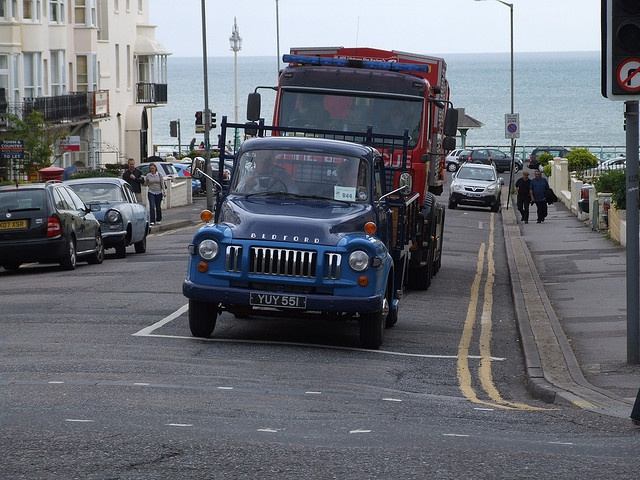Describe the objects in this image and their specific colors. I can see truck in blue, black, gray, navy, and darkblue tones, truck in blue, black, gray, and maroon tones, car in blue, black, gray, and darkgray tones, car in blue, black, gray, and darkgray tones, and car in blue, black, gray, darkgray, and lavender tones in this image. 